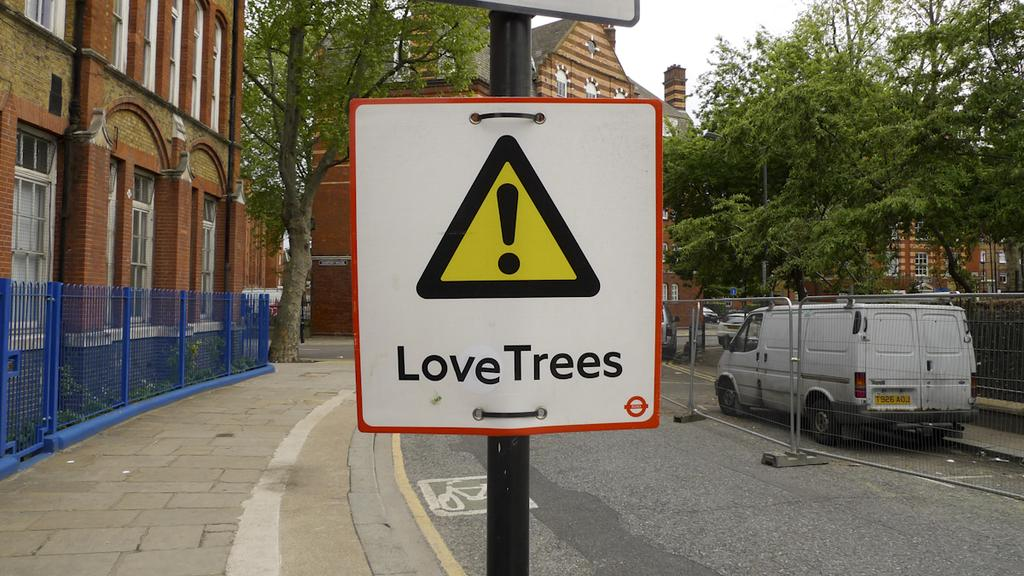<image>
Share a concise interpretation of the image provided. A sign has a triangle on it and the words Love Trees. 